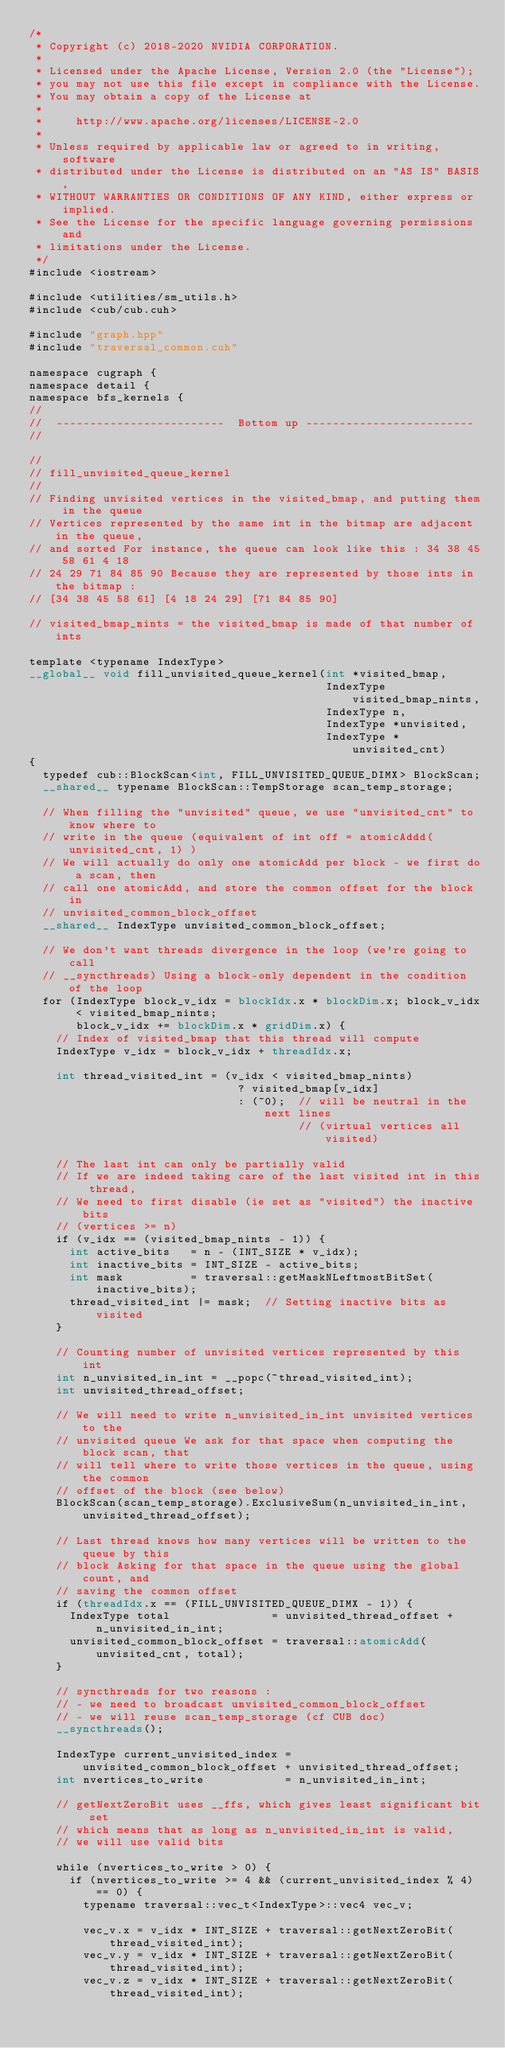Convert code to text. <code><loc_0><loc_0><loc_500><loc_500><_Cuda_>/*
 * Copyright (c) 2018-2020 NVIDIA CORPORATION.
 *
 * Licensed under the Apache License, Version 2.0 (the "License");
 * you may not use this file except in compliance with the License.
 * You may obtain a copy of the License at
 *
 *     http://www.apache.org/licenses/LICENSE-2.0
 *
 * Unless required by applicable law or agreed to in writing, software
 * distributed under the License is distributed on an "AS IS" BASIS,
 * WITHOUT WARRANTIES OR CONDITIONS OF ANY KIND, either express or implied.
 * See the License for the specific language governing permissions and
 * limitations under the License.
 */
#include <iostream>

#include <utilities/sm_utils.h>
#include <cub/cub.cuh>

#include "graph.hpp"
#include "traversal_common.cuh"

namespace cugraph {
namespace detail {
namespace bfs_kernels {
//
//  -------------------------  Bottom up -------------------------
//

//
// fill_unvisited_queue_kernel
//
// Finding unvisited vertices in the visited_bmap, and putting them in the queue
// Vertices represented by the same int in the bitmap are adjacent in the queue,
// and sorted For instance, the queue can look like this : 34 38 45 58 61 4 18
// 24 29 71 84 85 90 Because they are represented by those ints in the bitmap :
// [34 38 45 58 61] [4 18 24 29] [71 84 85 90]

// visited_bmap_nints = the visited_bmap is made of that number of ints

template <typename IndexType>
__global__ void fill_unvisited_queue_kernel(int *visited_bmap,
                                            IndexType visited_bmap_nints,
                                            IndexType n,
                                            IndexType *unvisited,
                                            IndexType *unvisited_cnt)
{
  typedef cub::BlockScan<int, FILL_UNVISITED_QUEUE_DIMX> BlockScan;
  __shared__ typename BlockScan::TempStorage scan_temp_storage;

  // When filling the "unvisited" queue, we use "unvisited_cnt" to know where to
  // write in the queue (equivalent of int off = atomicAddd(unvisited_cnt, 1) )
  // We will actually do only one atomicAdd per block - we first do a scan, then
  // call one atomicAdd, and store the common offset for the block in
  // unvisited_common_block_offset
  __shared__ IndexType unvisited_common_block_offset;

  // We don't want threads divergence in the loop (we're going to call
  // __syncthreads) Using a block-only dependent in the condition of the loop
  for (IndexType block_v_idx = blockIdx.x * blockDim.x; block_v_idx < visited_bmap_nints;
       block_v_idx += blockDim.x * gridDim.x) {
    // Index of visited_bmap that this thread will compute
    IndexType v_idx = block_v_idx + threadIdx.x;

    int thread_visited_int = (v_idx < visited_bmap_nints)
                               ? visited_bmap[v_idx]
                               : (~0);  // will be neutral in the next lines
                                        // (virtual vertices all visited)

    // The last int can only be partially valid
    // If we are indeed taking care of the last visited int in this thread,
    // We need to first disable (ie set as "visited") the inactive bits
    // (vertices >= n)
    if (v_idx == (visited_bmap_nints - 1)) {
      int active_bits   = n - (INT_SIZE * v_idx);
      int inactive_bits = INT_SIZE - active_bits;
      int mask          = traversal::getMaskNLeftmostBitSet(inactive_bits);
      thread_visited_int |= mask;  // Setting inactive bits as visited
    }

    // Counting number of unvisited vertices represented by this int
    int n_unvisited_in_int = __popc(~thread_visited_int);
    int unvisited_thread_offset;

    // We will need to write n_unvisited_in_int unvisited vertices to the
    // unvisited queue We ask for that space when computing the block scan, that
    // will tell where to write those vertices in the queue, using the common
    // offset of the block (see below)
    BlockScan(scan_temp_storage).ExclusiveSum(n_unvisited_in_int, unvisited_thread_offset);

    // Last thread knows how many vertices will be written to the queue by this
    // block Asking for that space in the queue using the global count, and
    // saving the common offset
    if (threadIdx.x == (FILL_UNVISITED_QUEUE_DIMX - 1)) {
      IndexType total               = unvisited_thread_offset + n_unvisited_in_int;
      unvisited_common_block_offset = traversal::atomicAdd(unvisited_cnt, total);
    }

    // syncthreads for two reasons :
    // - we need to broadcast unvisited_common_block_offset
    // - we will reuse scan_temp_storage (cf CUB doc)
    __syncthreads();

    IndexType current_unvisited_index = unvisited_common_block_offset + unvisited_thread_offset;
    int nvertices_to_write            = n_unvisited_in_int;

    // getNextZeroBit uses __ffs, which gives least significant bit set
    // which means that as long as n_unvisited_in_int is valid,
    // we will use valid bits

    while (nvertices_to_write > 0) {
      if (nvertices_to_write >= 4 && (current_unvisited_index % 4) == 0) {
        typename traversal::vec_t<IndexType>::vec4 vec_v;

        vec_v.x = v_idx * INT_SIZE + traversal::getNextZeroBit(thread_visited_int);
        vec_v.y = v_idx * INT_SIZE + traversal::getNextZeroBit(thread_visited_int);
        vec_v.z = v_idx * INT_SIZE + traversal::getNextZeroBit(thread_visited_int);</code> 